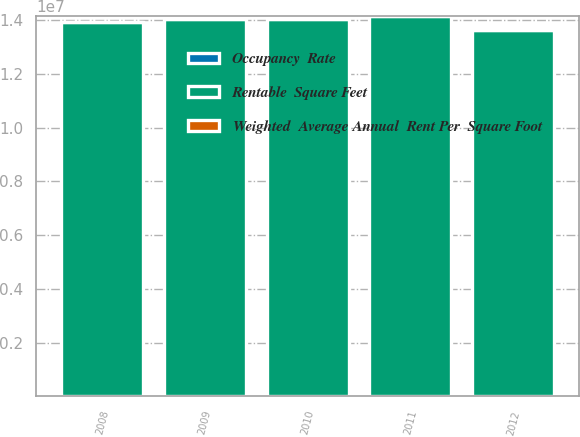Convert chart to OTSL. <chart><loc_0><loc_0><loc_500><loc_500><stacked_bar_chart><ecel><fcel>2012<fcel>2011<fcel>2010<fcel>2009<fcel>2008<nl><fcel>Rentable  Square Feet<fcel>1.3637e+07<fcel>1.4162e+07<fcel>1.4035e+07<fcel>1.4035e+07<fcel>1.3916e+07<nl><fcel>Occupancy  Rate<fcel>81.2<fcel>89.3<fcel>94.8<fcel>94.9<fcel>95.1<nl><fcel>Weighted  Average Annual  Rent Per  Square Foot<fcel>41.57<fcel>40.8<fcel>39.65<fcel>38.46<fcel>37.12<nl></chart> 